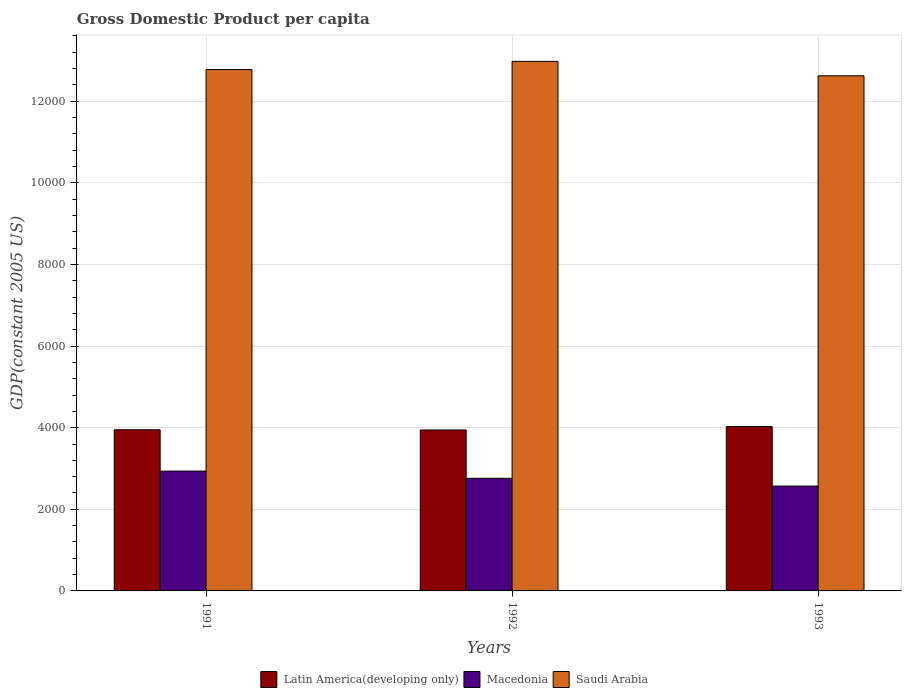How many groups of bars are there?
Keep it short and to the point. 3. Are the number of bars on each tick of the X-axis equal?
Give a very brief answer. Yes. How many bars are there on the 1st tick from the right?
Make the answer very short. 3. In how many cases, is the number of bars for a given year not equal to the number of legend labels?
Keep it short and to the point. 0. What is the GDP per capita in Macedonia in 1993?
Give a very brief answer. 2569.44. Across all years, what is the maximum GDP per capita in Latin America(developing only)?
Keep it short and to the point. 4027.17. Across all years, what is the minimum GDP per capita in Macedonia?
Provide a short and direct response. 2569.44. In which year was the GDP per capita in Macedonia minimum?
Provide a short and direct response. 1993. What is the total GDP per capita in Macedonia in the graph?
Provide a short and direct response. 8266.08. What is the difference between the GDP per capita in Latin America(developing only) in 1992 and that in 1993?
Make the answer very short. -82.87. What is the difference between the GDP per capita in Latin America(developing only) in 1993 and the GDP per capita in Saudi Arabia in 1991?
Make the answer very short. -8749.3. What is the average GDP per capita in Latin America(developing only) per year?
Offer a very short reply. 3973.41. In the year 1992, what is the difference between the GDP per capita in Saudi Arabia and GDP per capita in Macedonia?
Provide a short and direct response. 1.02e+04. In how many years, is the GDP per capita in Macedonia greater than 1200 US$?
Give a very brief answer. 3. What is the ratio of the GDP per capita in Latin America(developing only) in 1992 to that in 1993?
Offer a very short reply. 0.98. Is the GDP per capita in Latin America(developing only) in 1991 less than that in 1992?
Ensure brevity in your answer.  No. Is the difference between the GDP per capita in Saudi Arabia in 1991 and 1992 greater than the difference between the GDP per capita in Macedonia in 1991 and 1992?
Ensure brevity in your answer.  No. What is the difference between the highest and the second highest GDP per capita in Macedonia?
Your answer should be compact. 176.95. What is the difference between the highest and the lowest GDP per capita in Saudi Arabia?
Keep it short and to the point. 353.6. In how many years, is the GDP per capita in Latin America(developing only) greater than the average GDP per capita in Latin America(developing only) taken over all years?
Provide a succinct answer. 1. Is the sum of the GDP per capita in Macedonia in 1992 and 1993 greater than the maximum GDP per capita in Saudi Arabia across all years?
Your answer should be very brief. No. What does the 1st bar from the left in 1993 represents?
Your answer should be compact. Latin America(developing only). What does the 2nd bar from the right in 1993 represents?
Make the answer very short. Macedonia. Is it the case that in every year, the sum of the GDP per capita in Macedonia and GDP per capita in Latin America(developing only) is greater than the GDP per capita in Saudi Arabia?
Your answer should be compact. No. How many bars are there?
Make the answer very short. 9. Are all the bars in the graph horizontal?
Offer a terse response. No. How many years are there in the graph?
Give a very brief answer. 3. Does the graph contain grids?
Your answer should be compact. Yes. Where does the legend appear in the graph?
Make the answer very short. Bottom center. How are the legend labels stacked?
Your answer should be very brief. Horizontal. What is the title of the graph?
Give a very brief answer. Gross Domestic Product per capita. What is the label or title of the X-axis?
Provide a succinct answer. Years. What is the label or title of the Y-axis?
Your answer should be compact. GDP(constant 2005 US). What is the GDP(constant 2005 US) in Latin America(developing only) in 1991?
Ensure brevity in your answer.  3948.76. What is the GDP(constant 2005 US) in Macedonia in 1991?
Provide a short and direct response. 2936.79. What is the GDP(constant 2005 US) in Saudi Arabia in 1991?
Keep it short and to the point. 1.28e+04. What is the GDP(constant 2005 US) of Latin America(developing only) in 1992?
Your answer should be very brief. 3944.3. What is the GDP(constant 2005 US) of Macedonia in 1992?
Offer a terse response. 2759.84. What is the GDP(constant 2005 US) in Saudi Arabia in 1992?
Your answer should be very brief. 1.30e+04. What is the GDP(constant 2005 US) in Latin America(developing only) in 1993?
Offer a very short reply. 4027.17. What is the GDP(constant 2005 US) of Macedonia in 1993?
Give a very brief answer. 2569.44. What is the GDP(constant 2005 US) of Saudi Arabia in 1993?
Give a very brief answer. 1.26e+04. Across all years, what is the maximum GDP(constant 2005 US) in Latin America(developing only)?
Your answer should be very brief. 4027.17. Across all years, what is the maximum GDP(constant 2005 US) in Macedonia?
Your response must be concise. 2936.79. Across all years, what is the maximum GDP(constant 2005 US) in Saudi Arabia?
Your answer should be compact. 1.30e+04. Across all years, what is the minimum GDP(constant 2005 US) of Latin America(developing only)?
Give a very brief answer. 3944.3. Across all years, what is the minimum GDP(constant 2005 US) of Macedonia?
Your response must be concise. 2569.44. Across all years, what is the minimum GDP(constant 2005 US) of Saudi Arabia?
Provide a succinct answer. 1.26e+04. What is the total GDP(constant 2005 US) in Latin America(developing only) in the graph?
Keep it short and to the point. 1.19e+04. What is the total GDP(constant 2005 US) of Macedonia in the graph?
Your answer should be very brief. 8266.08. What is the total GDP(constant 2005 US) of Saudi Arabia in the graph?
Make the answer very short. 3.84e+04. What is the difference between the GDP(constant 2005 US) of Latin America(developing only) in 1991 and that in 1992?
Offer a terse response. 4.46. What is the difference between the GDP(constant 2005 US) in Macedonia in 1991 and that in 1992?
Offer a very short reply. 176.95. What is the difference between the GDP(constant 2005 US) of Saudi Arabia in 1991 and that in 1992?
Ensure brevity in your answer.  -201.08. What is the difference between the GDP(constant 2005 US) in Latin America(developing only) in 1991 and that in 1993?
Give a very brief answer. -78.41. What is the difference between the GDP(constant 2005 US) of Macedonia in 1991 and that in 1993?
Provide a succinct answer. 367.35. What is the difference between the GDP(constant 2005 US) in Saudi Arabia in 1991 and that in 1993?
Make the answer very short. 152.52. What is the difference between the GDP(constant 2005 US) of Latin America(developing only) in 1992 and that in 1993?
Your response must be concise. -82.87. What is the difference between the GDP(constant 2005 US) of Macedonia in 1992 and that in 1993?
Provide a short and direct response. 190.4. What is the difference between the GDP(constant 2005 US) in Saudi Arabia in 1992 and that in 1993?
Keep it short and to the point. 353.6. What is the difference between the GDP(constant 2005 US) in Latin America(developing only) in 1991 and the GDP(constant 2005 US) in Macedonia in 1992?
Provide a succinct answer. 1188.91. What is the difference between the GDP(constant 2005 US) in Latin America(developing only) in 1991 and the GDP(constant 2005 US) in Saudi Arabia in 1992?
Provide a short and direct response. -9028.79. What is the difference between the GDP(constant 2005 US) of Macedonia in 1991 and the GDP(constant 2005 US) of Saudi Arabia in 1992?
Your response must be concise. -1.00e+04. What is the difference between the GDP(constant 2005 US) of Latin America(developing only) in 1991 and the GDP(constant 2005 US) of Macedonia in 1993?
Keep it short and to the point. 1379.32. What is the difference between the GDP(constant 2005 US) in Latin America(developing only) in 1991 and the GDP(constant 2005 US) in Saudi Arabia in 1993?
Your answer should be compact. -8675.19. What is the difference between the GDP(constant 2005 US) of Macedonia in 1991 and the GDP(constant 2005 US) of Saudi Arabia in 1993?
Give a very brief answer. -9687.16. What is the difference between the GDP(constant 2005 US) in Latin America(developing only) in 1992 and the GDP(constant 2005 US) in Macedonia in 1993?
Your answer should be compact. 1374.86. What is the difference between the GDP(constant 2005 US) of Latin America(developing only) in 1992 and the GDP(constant 2005 US) of Saudi Arabia in 1993?
Provide a succinct answer. -8679.65. What is the difference between the GDP(constant 2005 US) in Macedonia in 1992 and the GDP(constant 2005 US) in Saudi Arabia in 1993?
Your answer should be compact. -9864.11. What is the average GDP(constant 2005 US) in Latin America(developing only) per year?
Offer a terse response. 3973.41. What is the average GDP(constant 2005 US) of Macedonia per year?
Your answer should be very brief. 2755.36. What is the average GDP(constant 2005 US) in Saudi Arabia per year?
Give a very brief answer. 1.28e+04. In the year 1991, what is the difference between the GDP(constant 2005 US) of Latin America(developing only) and GDP(constant 2005 US) of Macedonia?
Make the answer very short. 1011.96. In the year 1991, what is the difference between the GDP(constant 2005 US) of Latin America(developing only) and GDP(constant 2005 US) of Saudi Arabia?
Your response must be concise. -8827.71. In the year 1991, what is the difference between the GDP(constant 2005 US) in Macedonia and GDP(constant 2005 US) in Saudi Arabia?
Provide a short and direct response. -9839.68. In the year 1992, what is the difference between the GDP(constant 2005 US) of Latin America(developing only) and GDP(constant 2005 US) of Macedonia?
Ensure brevity in your answer.  1184.45. In the year 1992, what is the difference between the GDP(constant 2005 US) of Latin America(developing only) and GDP(constant 2005 US) of Saudi Arabia?
Offer a very short reply. -9033.25. In the year 1992, what is the difference between the GDP(constant 2005 US) in Macedonia and GDP(constant 2005 US) in Saudi Arabia?
Make the answer very short. -1.02e+04. In the year 1993, what is the difference between the GDP(constant 2005 US) in Latin America(developing only) and GDP(constant 2005 US) in Macedonia?
Offer a terse response. 1457.73. In the year 1993, what is the difference between the GDP(constant 2005 US) in Latin America(developing only) and GDP(constant 2005 US) in Saudi Arabia?
Your answer should be compact. -8596.78. In the year 1993, what is the difference between the GDP(constant 2005 US) in Macedonia and GDP(constant 2005 US) in Saudi Arabia?
Keep it short and to the point. -1.01e+04. What is the ratio of the GDP(constant 2005 US) of Macedonia in 1991 to that in 1992?
Ensure brevity in your answer.  1.06. What is the ratio of the GDP(constant 2005 US) in Saudi Arabia in 1991 to that in 1992?
Offer a very short reply. 0.98. What is the ratio of the GDP(constant 2005 US) of Latin America(developing only) in 1991 to that in 1993?
Your answer should be compact. 0.98. What is the ratio of the GDP(constant 2005 US) in Macedonia in 1991 to that in 1993?
Ensure brevity in your answer.  1.14. What is the ratio of the GDP(constant 2005 US) of Saudi Arabia in 1991 to that in 1993?
Your response must be concise. 1.01. What is the ratio of the GDP(constant 2005 US) of Latin America(developing only) in 1992 to that in 1993?
Ensure brevity in your answer.  0.98. What is the ratio of the GDP(constant 2005 US) of Macedonia in 1992 to that in 1993?
Ensure brevity in your answer.  1.07. What is the ratio of the GDP(constant 2005 US) in Saudi Arabia in 1992 to that in 1993?
Make the answer very short. 1.03. What is the difference between the highest and the second highest GDP(constant 2005 US) of Latin America(developing only)?
Offer a terse response. 78.41. What is the difference between the highest and the second highest GDP(constant 2005 US) of Macedonia?
Your answer should be very brief. 176.95. What is the difference between the highest and the second highest GDP(constant 2005 US) in Saudi Arabia?
Offer a very short reply. 201.08. What is the difference between the highest and the lowest GDP(constant 2005 US) in Latin America(developing only)?
Provide a succinct answer. 82.87. What is the difference between the highest and the lowest GDP(constant 2005 US) in Macedonia?
Your answer should be very brief. 367.35. What is the difference between the highest and the lowest GDP(constant 2005 US) in Saudi Arabia?
Make the answer very short. 353.6. 